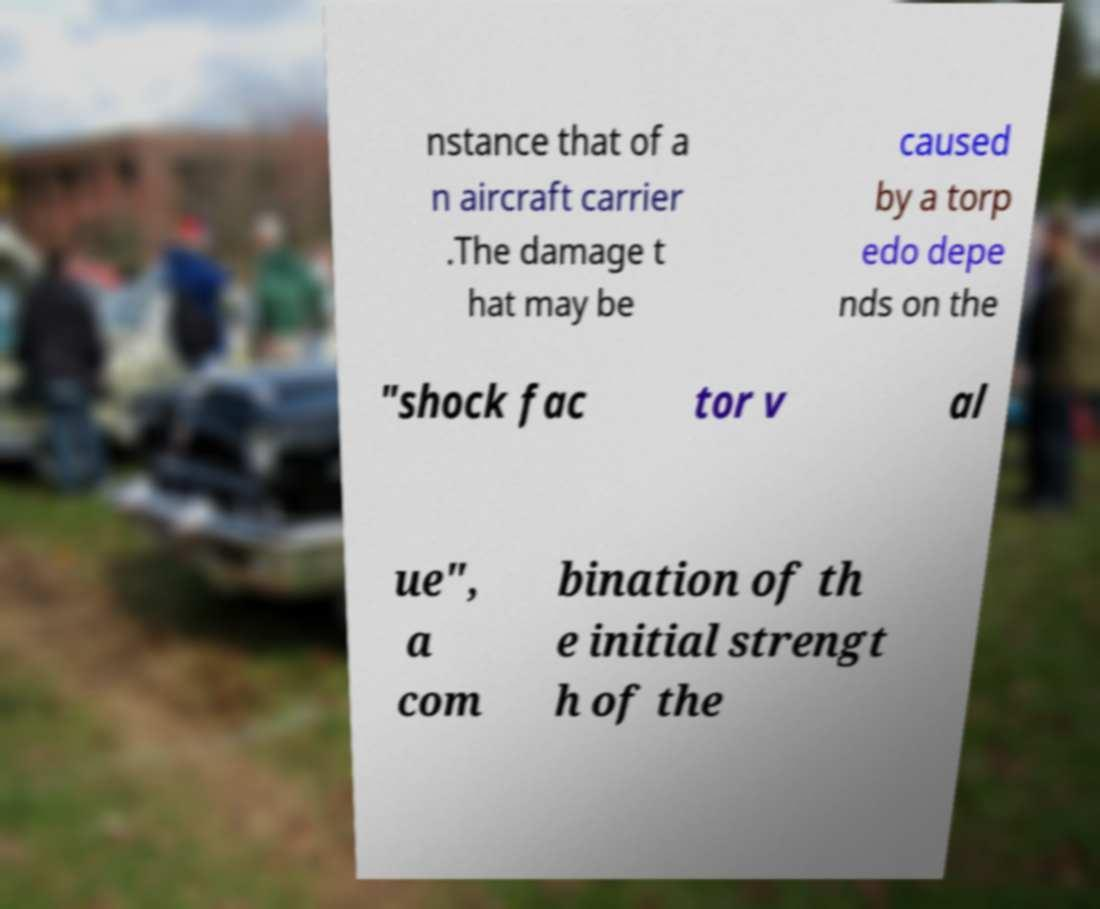I need the written content from this picture converted into text. Can you do that? nstance that of a n aircraft carrier .The damage t hat may be caused by a torp edo depe nds on the "shock fac tor v al ue", a com bination of th e initial strengt h of the 